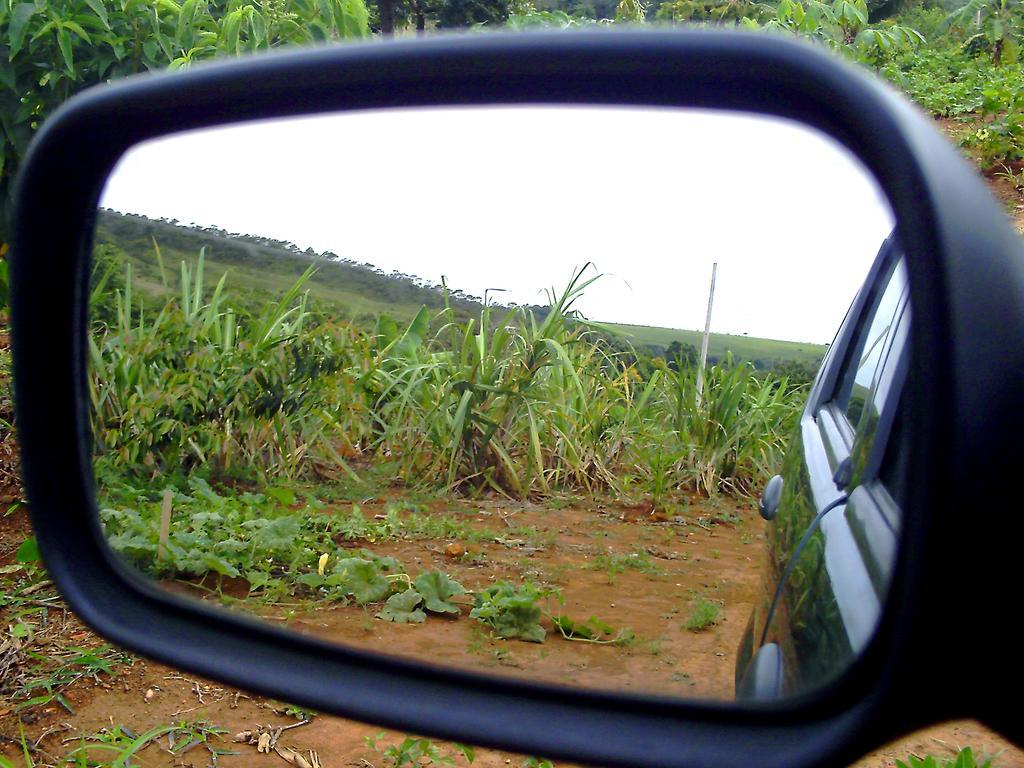Describe this image in one or two sentences. In this image, we can see reflection of plants, pole, car and sky on side mirror. There are some plants at the top of the image. 